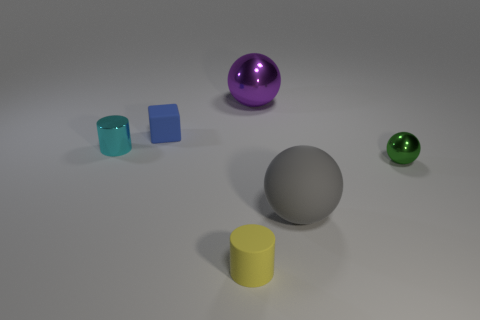There is a small rubber thing behind the yellow thing; is it the same shape as the gray thing? While both the small object behind the yellow cylinder and the gray object are somewhat similar in that they are both rounded, they are not the same shape. The gray object is a perfect sphere, while the small object you mentioned has a different shape with a unique edge, making it distinct from the spherical gray one. 